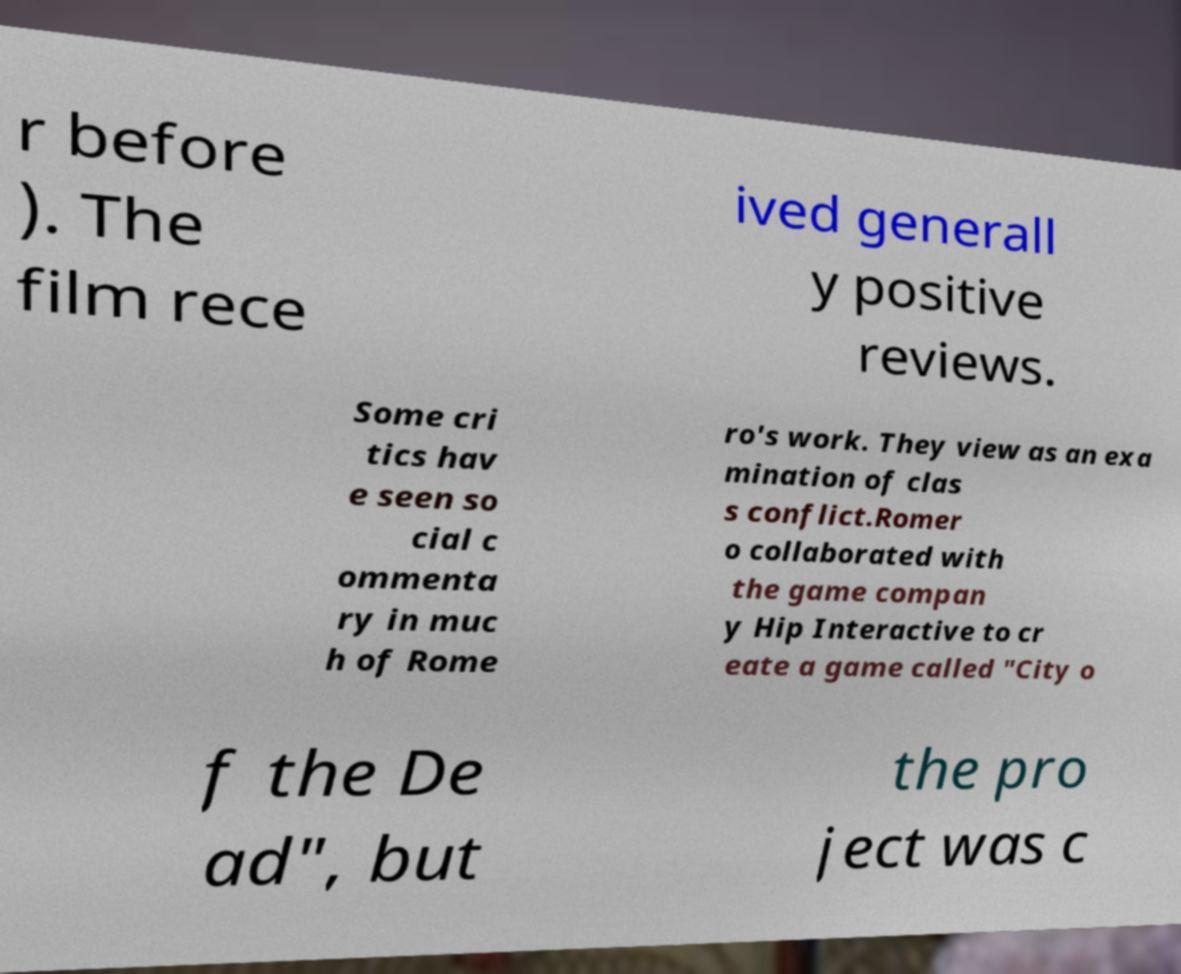Please read and relay the text visible in this image. What does it say? r before ). The film rece ived generall y positive reviews. Some cri tics hav e seen so cial c ommenta ry in muc h of Rome ro's work. They view as an exa mination of clas s conflict.Romer o collaborated with the game compan y Hip Interactive to cr eate a game called "City o f the De ad", but the pro ject was c 